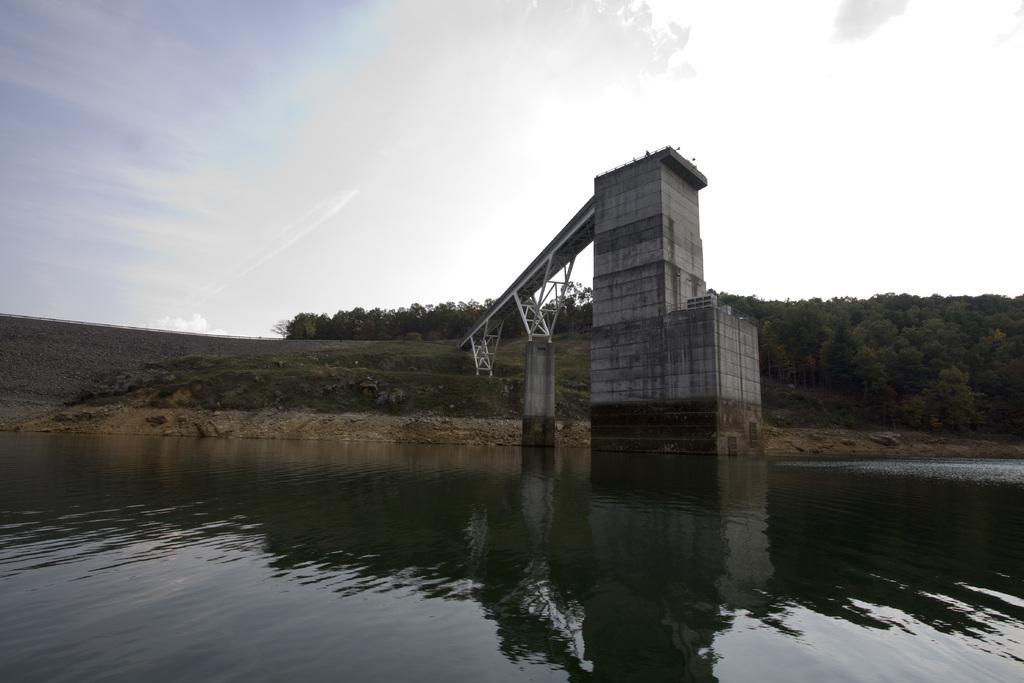Describe this image in one or two sentences. At the bottom of the picture, we see water and this water might be in the pond. In the middle of the picture, we see the tower and a bridge. There are trees in the background. At the top, we see the sky. 